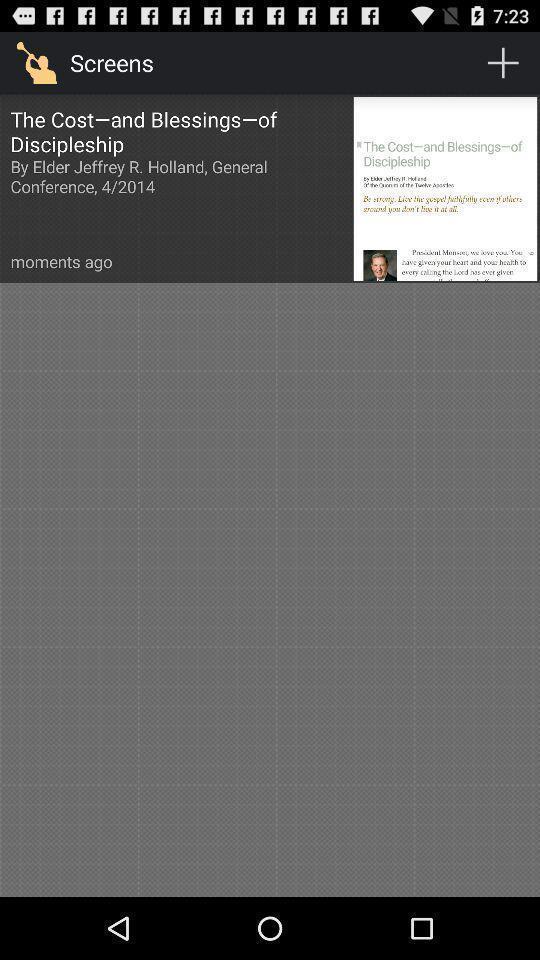Give me a summary of this screen capture. Page shows the gospel video details on study app. 